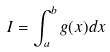Convert formula to latex. <formula><loc_0><loc_0><loc_500><loc_500>I = \int _ { a } ^ { b } g ( x ) d x</formula> 